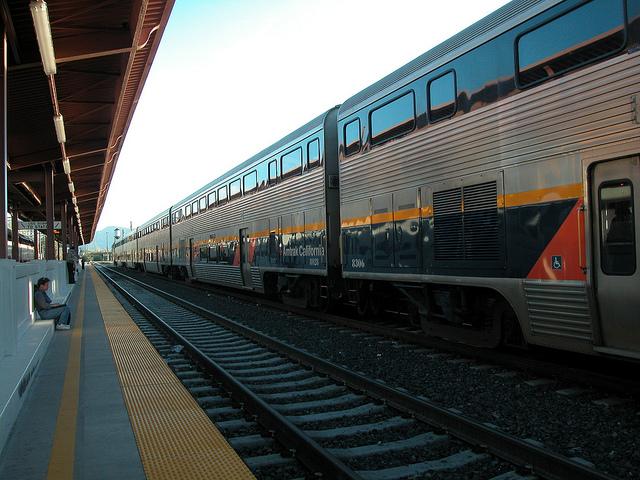Could you touch one train from the other train?
Write a very short answer. No. Is the train in the station or outside of it?
Keep it brief. Outside. Does the train move quickly?
Concise answer only. Yes. What is the reflection of?
Concise answer only. Train station. Is anyone waiting for the train?
Answer briefly. Yes. How many sets of train tracks are there?
Keep it brief. 2. Is this a busy train station?
Answer briefly. No. What distinguishes the doors of the train from the train itself?
Quick response, please. They open. Are there any people in this photo?
Quick response, please. Yes. Has this train been used recently?
Write a very short answer. Yes. 